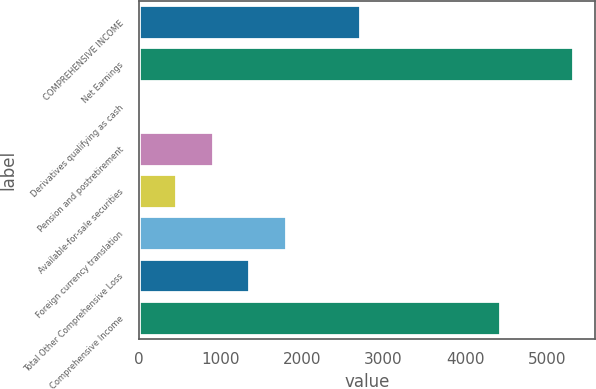Convert chart. <chart><loc_0><loc_0><loc_500><loc_500><bar_chart><fcel>COMPREHENSIVE INCOME<fcel>Net Earnings<fcel>Derivatives qualifying as cash<fcel>Pension and postretirement<fcel>Available-for-sale securities<fcel>Foreign currency translation<fcel>Total Other Comprehensive Loss<fcel>Comprehensive Income<nl><fcel>2705.8<fcel>5322.6<fcel>4<fcel>904.6<fcel>454.3<fcel>1805.2<fcel>1354.9<fcel>4422<nl></chart> 